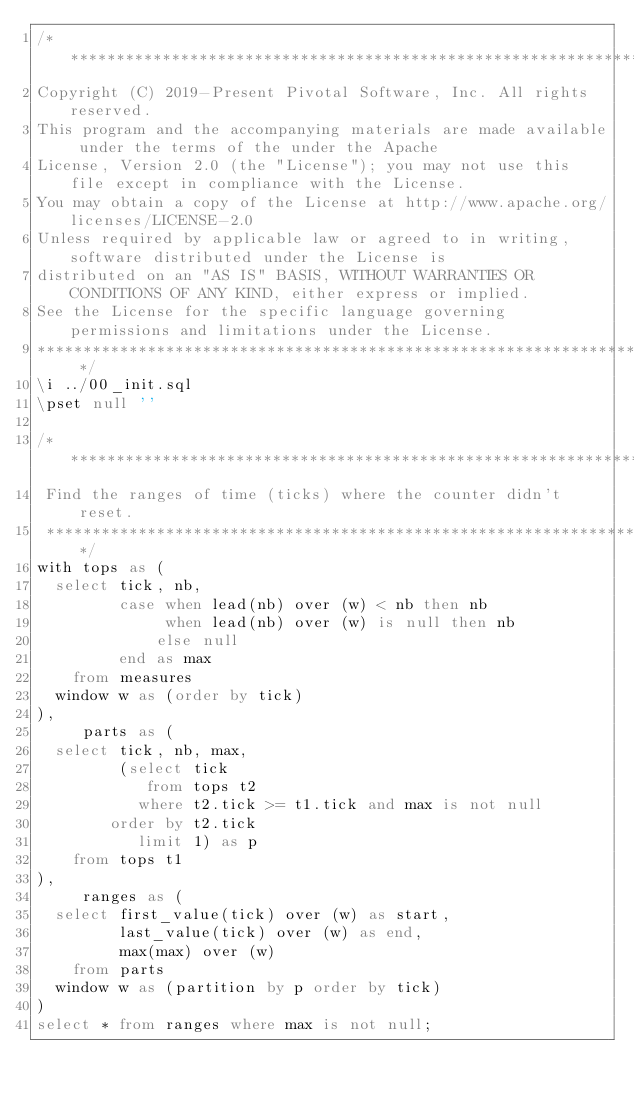Convert code to text. <code><loc_0><loc_0><loc_500><loc_500><_SQL_>/* *******************************************************************************************************
Copyright (C) 2019-Present Pivotal Software, Inc. All rights reserved.
This program and the accompanying materials are made available under the terms of the under the Apache
License, Version 2.0 (the "License"); you may not use this file except in compliance with the License.
You may obtain a copy of the License at http://www.apache.org/licenses/LICENSE-2.0
Unless required by applicable law or agreed to in writing, software distributed under the License is
distributed on an "AS IS" BASIS, WITHOUT WARRANTIES OR CONDITIONS OF ANY KIND, either express or implied.
See the License for the specific language governing permissions and limitations under the License.
******************************************************************************************************* */
\i ../00_init.sql
\pset null ''

/**********************************************************************
 Find the ranges of time (ticks) where the counter didn't reset.
 **********************************************************************/
with tops as (
  select tick, nb,
         case when lead(nb) over (w) < nb then nb
              when lead(nb) over (w) is null then nb
             else null
         end as max
    from measures
  window w as (order by tick)
),
     parts as (
  select tick, nb, max,
         (select tick
            from tops t2
           where t2.tick >= t1.tick and max is not null
        order by t2.tick
           limit 1) as p
    from tops t1
),
     ranges as (
  select first_value(tick) over (w) as start,
         last_value(tick) over (w) as end,
         max(max) over (w)
    from parts
  window w as (partition by p order by tick)
)
select * from ranges where max is not null;
</code> 